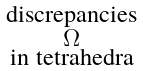<formula> <loc_0><loc_0><loc_500><loc_500>\begin{smallmatrix} \text {discrepancies} \\ \Omega \\ \text {in tetrahedra} \end{smallmatrix}</formula> 